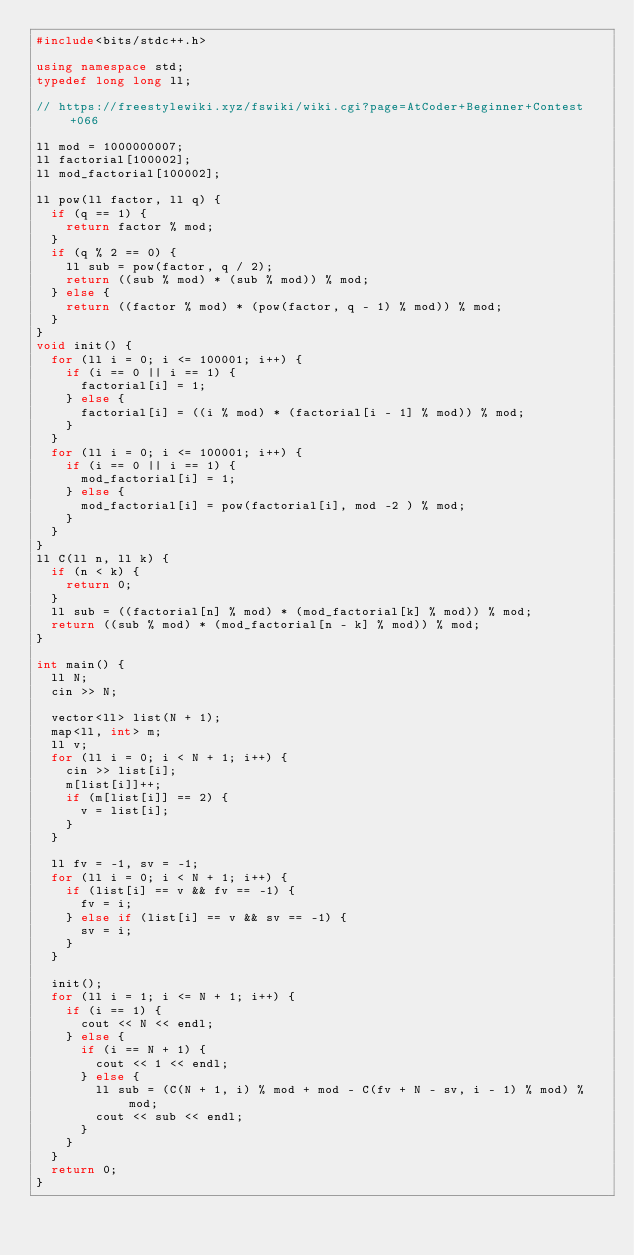Convert code to text. <code><loc_0><loc_0><loc_500><loc_500><_C++_>#include<bits/stdc++.h>

using namespace std;
typedef long long ll;

// https://freestylewiki.xyz/fswiki/wiki.cgi?page=AtCoder+Beginner+Contest+066

ll mod = 1000000007;
ll factorial[100002];
ll mod_factorial[100002];

ll pow(ll factor, ll q) {
  if (q == 1) {
    return factor % mod;
  }
  if (q % 2 == 0) {
    ll sub = pow(factor, q / 2);
    return ((sub % mod) * (sub % mod)) % mod;
  } else {
    return ((factor % mod) * (pow(factor, q - 1) % mod)) % mod;
  }
}
void init() {
  for (ll i = 0; i <= 100001; i++) {
    if (i == 0 || i == 1) {
      factorial[i] = 1;
    } else {
      factorial[i] = ((i % mod) * (factorial[i - 1] % mod)) % mod;
    }
  }
  for (ll i = 0; i <= 100001; i++) {
    if (i == 0 || i == 1) {
      mod_factorial[i] = 1;
    } else {
      mod_factorial[i] = pow(factorial[i], mod -2 ) % mod;
    }
  }
}
ll C(ll n, ll k) {
  if (n < k) {
    return 0;
  }
  ll sub = ((factorial[n] % mod) * (mod_factorial[k] % mod)) % mod;
  return ((sub % mod) * (mod_factorial[n - k] % mod)) % mod;
}

int main() {
  ll N;
  cin >> N;

  vector<ll> list(N + 1);
  map<ll, int> m;
  ll v;
  for (ll i = 0; i < N + 1; i++) {
    cin >> list[i];
    m[list[i]]++;
    if (m[list[i]] == 2) {
      v = list[i];
    }
  }

  ll fv = -1, sv = -1;
  for (ll i = 0; i < N + 1; i++) {
    if (list[i] == v && fv == -1) {
      fv = i;
    } else if (list[i] == v && sv == -1) {
      sv = i;
    }
  }

  init();
  for (ll i = 1; i <= N + 1; i++) {
    if (i == 1) {
      cout << N << endl;
    } else {
      if (i == N + 1) {
        cout << 1 << endl;
      } else {
        ll sub = (C(N + 1, i) % mod + mod - C(fv + N - sv, i - 1) % mod) % mod;
        cout << sub << endl;
      }
    }
  }
  return 0;
}
</code> 